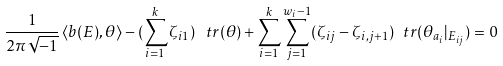<formula> <loc_0><loc_0><loc_500><loc_500>\frac { 1 } { 2 \pi \sqrt { - 1 } } \, \langle b ( E ) , \theta \rangle - ( \sum _ { i = 1 } ^ { k } \zeta _ { i 1 } ) \, \ t r ( \theta ) + \sum _ { i = 1 } ^ { k } \sum _ { j = 1 } ^ { w _ { i } - 1 } ( \zeta _ { i j } - \zeta _ { i , j + 1 } ) \ t r ( \theta _ { a _ { i } } | _ { E _ { i j } } ) = 0</formula> 